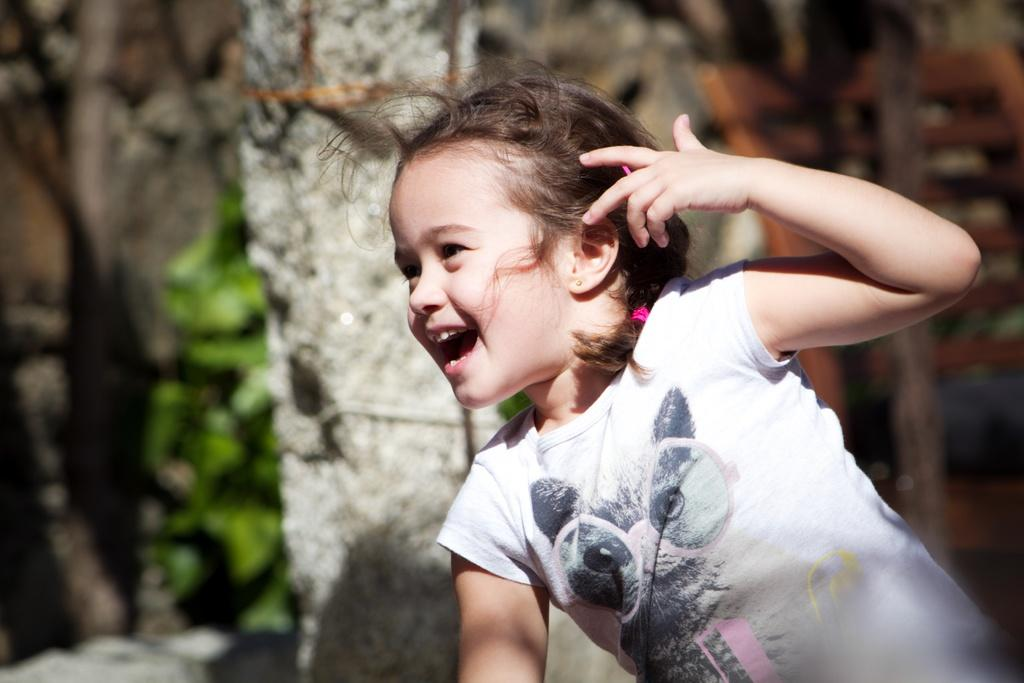What is the main subject of the image? The main subject of the image is a girl. What is the girl doing in the image? The girl is smiling in the image. What can be seen in the background of the image? There are trees in the background of the image. How far away is the girl from the stick in the image? There is no stick present in the image. Is the girl sleeping in the image? No, the girl is not sleeping in the image; she is smiling. 